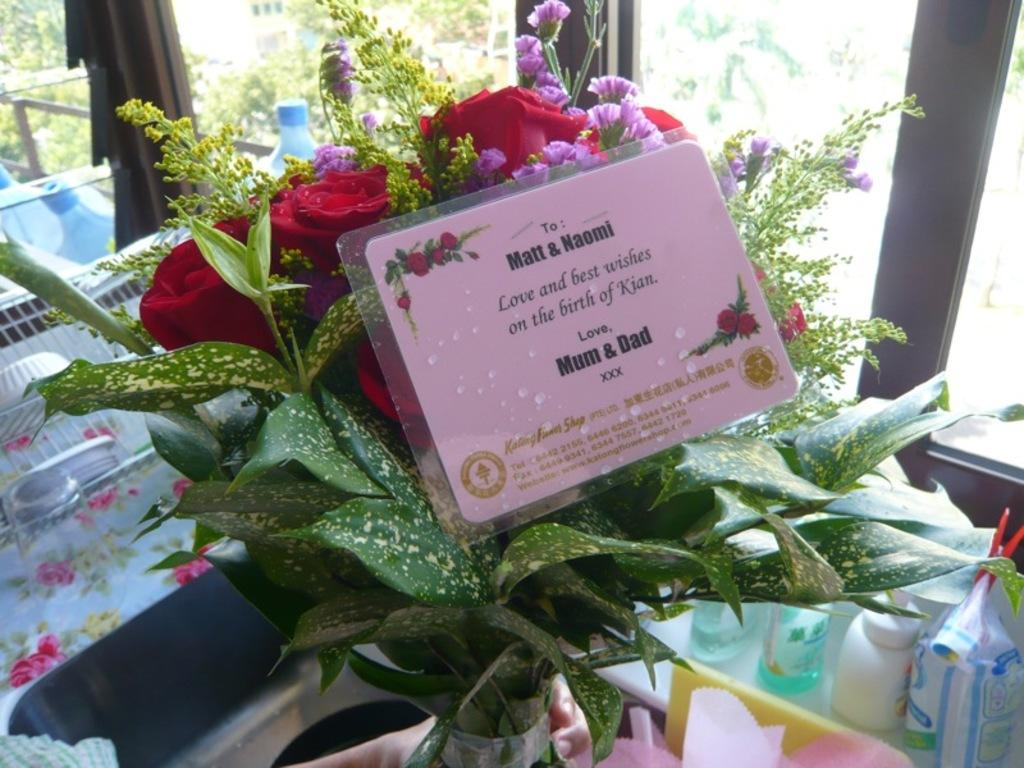What is the main subject in the center of the image? There is a flower vase in the center of the image. Can you describe the objects at the bottom of the image? Unfortunately, the facts provided do not give any information about the objects at the bottom of the image. How many drawers are visible in the image? There are no drawers present in the image. What type of scissors can be seen cutting through the flowers in the vase? There are no scissors or flowers being cut in the image; it only features a flower vase. 